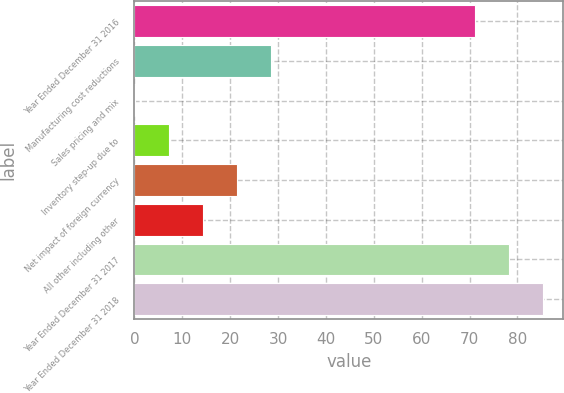<chart> <loc_0><loc_0><loc_500><loc_500><bar_chart><fcel>Year Ended December 31 2016<fcel>Manufacturing cost reductions<fcel>Sales pricing and mix<fcel>Inventory step-up due to<fcel>Net impact of foreign currency<fcel>All other including other<fcel>Year Ended December 31 2017<fcel>Year Ended December 31 2018<nl><fcel>71.1<fcel>28.62<fcel>0.1<fcel>7.23<fcel>21.49<fcel>14.36<fcel>78.23<fcel>85.36<nl></chart> 